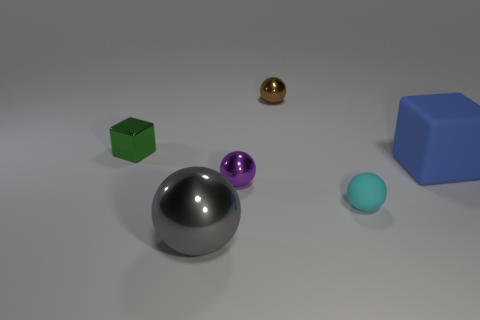Subtract all purple metallic spheres. How many spheres are left? 3 Subtract all cyan balls. How many balls are left? 3 Add 1 rubber objects. How many objects exist? 7 Subtract all balls. How many objects are left? 2 Subtract all cyan spheres. How many brown blocks are left? 0 Subtract all gray blocks. Subtract all purple cylinders. How many blocks are left? 2 Subtract all small shiny things. Subtract all purple things. How many objects are left? 2 Add 1 matte things. How many matte things are left? 3 Add 6 large shiny spheres. How many large shiny spheres exist? 7 Subtract 1 brown spheres. How many objects are left? 5 